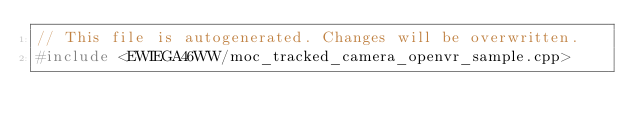<code> <loc_0><loc_0><loc_500><loc_500><_C++_>// This file is autogenerated. Changes will be overwritten.
#include <EWIEGA46WW/moc_tracked_camera_openvr_sample.cpp>
</code> 